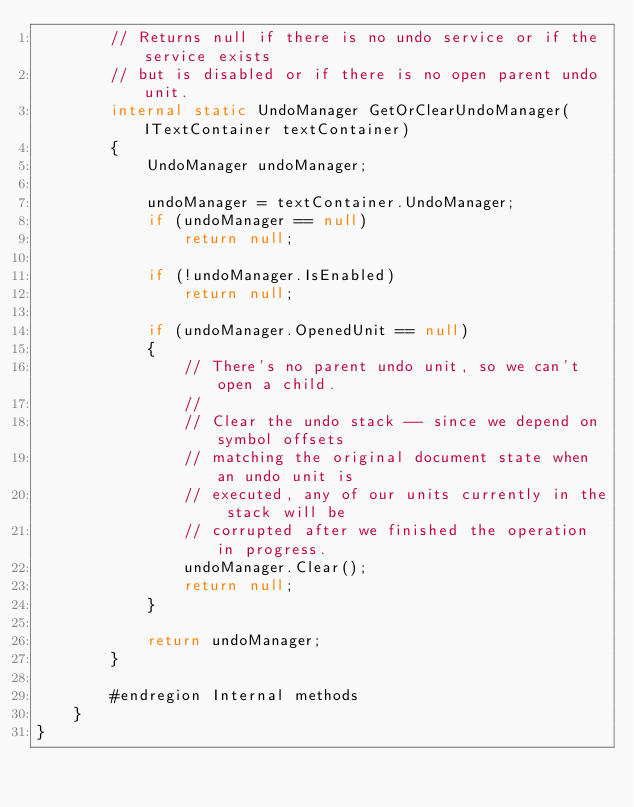<code> <loc_0><loc_0><loc_500><loc_500><_C#_>        // Returns null if there is no undo service or if the service exists
        // but is disabled or if there is no open parent undo unit.
        internal static UndoManager GetOrClearUndoManager(ITextContainer textContainer)
        {
            UndoManager undoManager;

            undoManager = textContainer.UndoManager;
            if (undoManager == null)
                return null;

            if (!undoManager.IsEnabled)
                return null;

            if (undoManager.OpenedUnit == null)
            {
                // There's no parent undo unit, so we can't open a child.
                //
                // Clear the undo stack -- since we depend on symbol offsets
                // matching the original document state when an undo unit is
                // executed, any of our units currently in the stack will be
                // corrupted after we finished the operation in progress.
                undoManager.Clear();
                return null;
            }

            return undoManager;
        }

        #endregion Internal methods
    }
}

</code> 